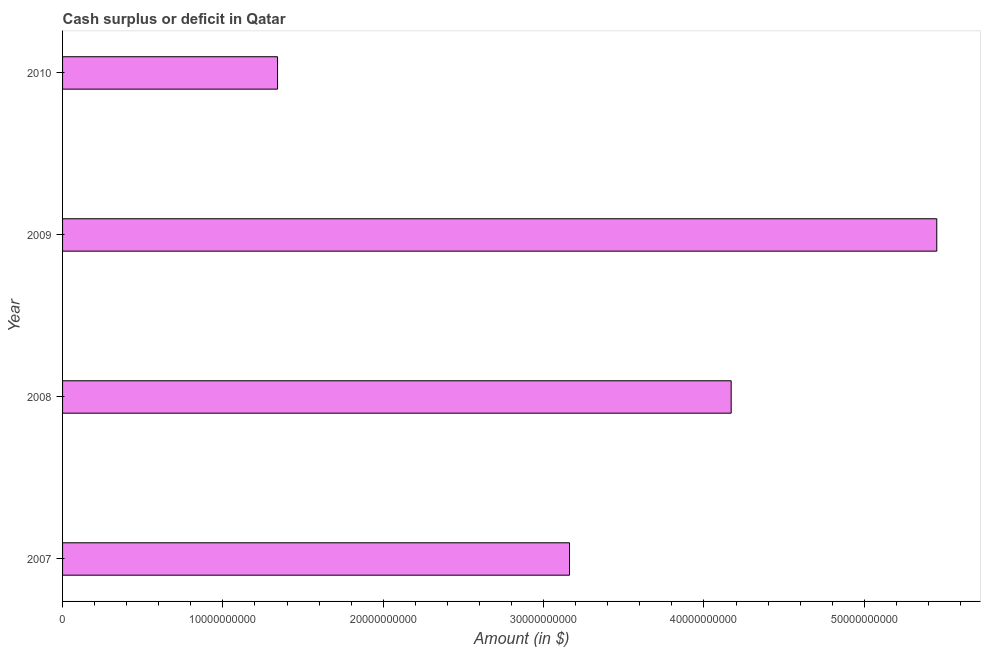Does the graph contain any zero values?
Offer a terse response. No. Does the graph contain grids?
Ensure brevity in your answer.  No. What is the title of the graph?
Your answer should be very brief. Cash surplus or deficit in Qatar. What is the label or title of the X-axis?
Offer a terse response. Amount (in $). What is the cash surplus or deficit in 2008?
Give a very brief answer. 4.17e+1. Across all years, what is the maximum cash surplus or deficit?
Your answer should be very brief. 5.45e+1. Across all years, what is the minimum cash surplus or deficit?
Provide a succinct answer. 1.34e+1. What is the sum of the cash surplus or deficit?
Provide a short and direct response. 1.41e+11. What is the difference between the cash surplus or deficit in 2009 and 2010?
Your response must be concise. 4.11e+1. What is the average cash surplus or deficit per year?
Your response must be concise. 3.53e+1. What is the median cash surplus or deficit?
Offer a very short reply. 3.67e+1. Do a majority of the years between 2009 and 2010 (inclusive) have cash surplus or deficit greater than 14000000000 $?
Give a very brief answer. No. What is the ratio of the cash surplus or deficit in 2009 to that in 2010?
Make the answer very short. 4.07. Is the cash surplus or deficit in 2007 less than that in 2008?
Your answer should be very brief. Yes. Is the difference between the cash surplus or deficit in 2008 and 2009 greater than the difference between any two years?
Give a very brief answer. No. What is the difference between the highest and the second highest cash surplus or deficit?
Keep it short and to the point. 1.28e+1. Is the sum of the cash surplus or deficit in 2007 and 2008 greater than the maximum cash surplus or deficit across all years?
Make the answer very short. Yes. What is the difference between the highest and the lowest cash surplus or deficit?
Ensure brevity in your answer.  4.11e+1. In how many years, is the cash surplus or deficit greater than the average cash surplus or deficit taken over all years?
Provide a short and direct response. 2. How many bars are there?
Give a very brief answer. 4. How many years are there in the graph?
Make the answer very short. 4. What is the difference between two consecutive major ticks on the X-axis?
Your answer should be very brief. 1.00e+1. Are the values on the major ticks of X-axis written in scientific E-notation?
Offer a very short reply. No. What is the Amount (in $) in 2007?
Provide a succinct answer. 3.16e+1. What is the Amount (in $) in 2008?
Provide a succinct answer. 4.17e+1. What is the Amount (in $) in 2009?
Provide a succinct answer. 5.45e+1. What is the Amount (in $) in 2010?
Make the answer very short. 1.34e+1. What is the difference between the Amount (in $) in 2007 and 2008?
Offer a very short reply. -1.01e+1. What is the difference between the Amount (in $) in 2007 and 2009?
Your answer should be very brief. -2.29e+1. What is the difference between the Amount (in $) in 2007 and 2010?
Your answer should be very brief. 1.82e+1. What is the difference between the Amount (in $) in 2008 and 2009?
Your response must be concise. -1.28e+1. What is the difference between the Amount (in $) in 2008 and 2010?
Your answer should be very brief. 2.83e+1. What is the difference between the Amount (in $) in 2009 and 2010?
Your answer should be compact. 4.11e+1. What is the ratio of the Amount (in $) in 2007 to that in 2008?
Your answer should be compact. 0.76. What is the ratio of the Amount (in $) in 2007 to that in 2009?
Keep it short and to the point. 0.58. What is the ratio of the Amount (in $) in 2007 to that in 2010?
Make the answer very short. 2.36. What is the ratio of the Amount (in $) in 2008 to that in 2009?
Give a very brief answer. 0.77. What is the ratio of the Amount (in $) in 2008 to that in 2010?
Keep it short and to the point. 3.11. What is the ratio of the Amount (in $) in 2009 to that in 2010?
Make the answer very short. 4.07. 